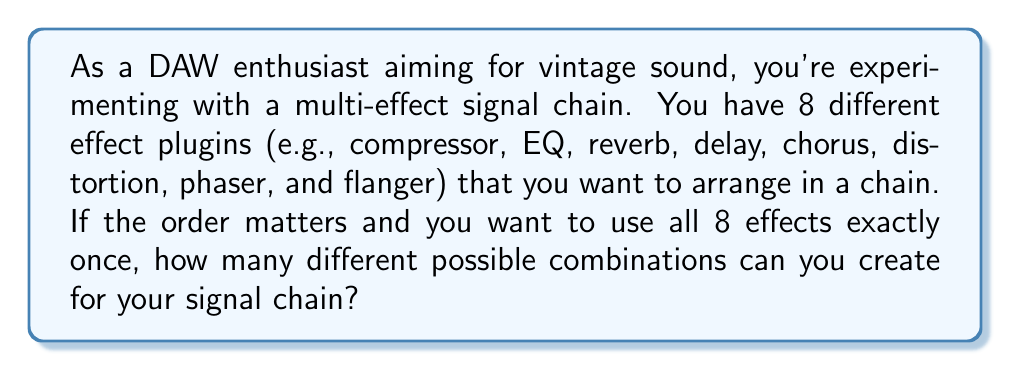Show me your answer to this math problem. This problem is a perfect application of permutations in number theory. Since we're arranging all 8 effects in a specific order, and each effect is used exactly once, this is a straightforward permutation problem.

The number of permutations of $n$ distinct objects is given by the factorial of $n$, denoted as $n!$.

In this case, we have 8 distinct effects, so $n = 8$.

Therefore, the number of possible combinations is:

$$8! = 8 \times 7 \times 6 \times 5 \times 4 \times 3 \times 2 \times 1$$

Let's calculate this step by step:

$$\begin{align*}
8! &= 8 \times 7 \times 6 \times 5 \times 4 \times 3 \times 2 \times 1 \\
   &= 56 \times 6 \times 5 \times 4 \times 3 \times 2 \times 1 \\
   &= 336 \times 5 \times 4 \times 3 \times 2 \times 1 \\
   &= 1,680 \times 4 \times 3 \times 2 \times 1 \\
   &= 6,720 \times 3 \times 2 \times 1 \\
   &= 20,160 \times 2 \times 1 \\
   &= 40,320
\end{align*}$$

This means you can create 40,320 different combinations of your 8 effects in the signal chain.
Answer: $40,320$ 